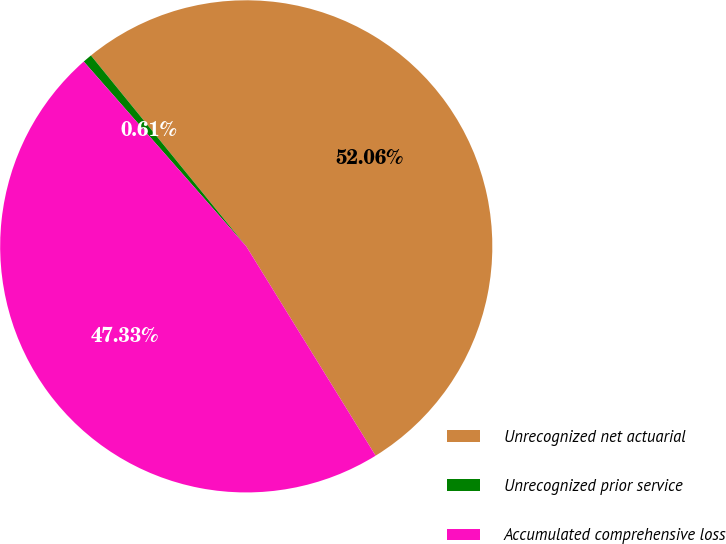Convert chart to OTSL. <chart><loc_0><loc_0><loc_500><loc_500><pie_chart><fcel>Unrecognized net actuarial<fcel>Unrecognized prior service<fcel>Accumulated comprehensive loss<nl><fcel>52.06%<fcel>0.61%<fcel>47.33%<nl></chart> 